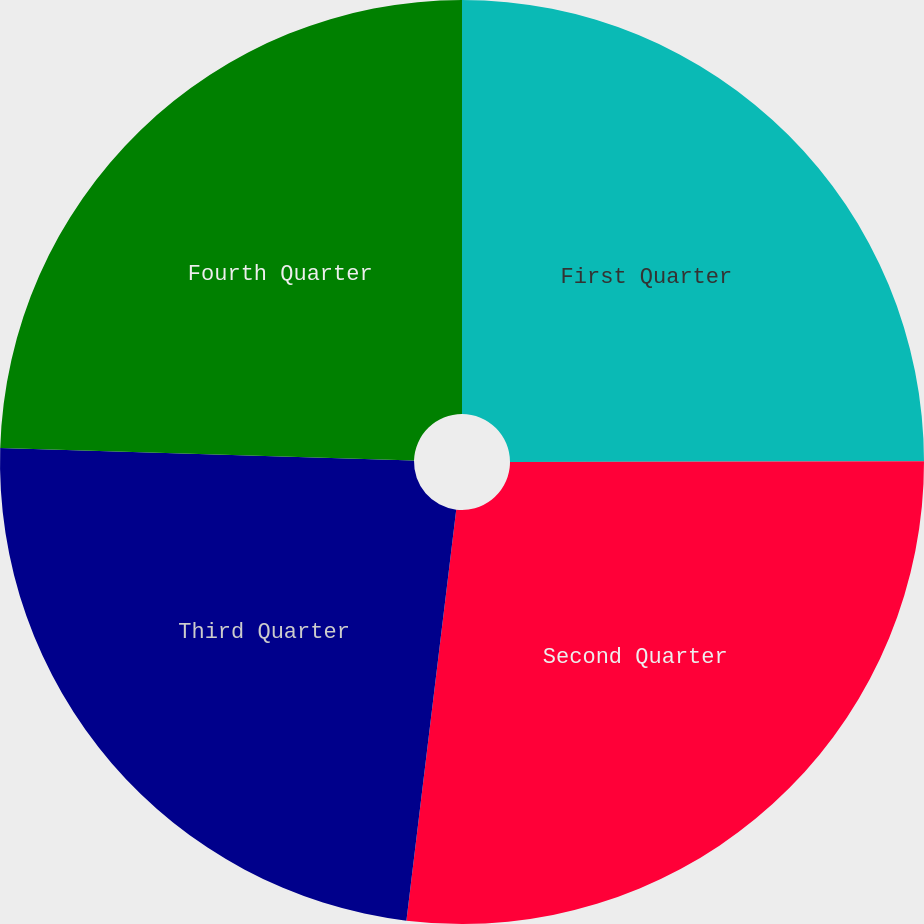Convert chart. <chart><loc_0><loc_0><loc_500><loc_500><pie_chart><fcel>First Quarter<fcel>Second Quarter<fcel>Third Quarter<fcel>Fourth Quarter<nl><fcel>24.97%<fcel>26.95%<fcel>23.56%<fcel>24.52%<nl></chart> 